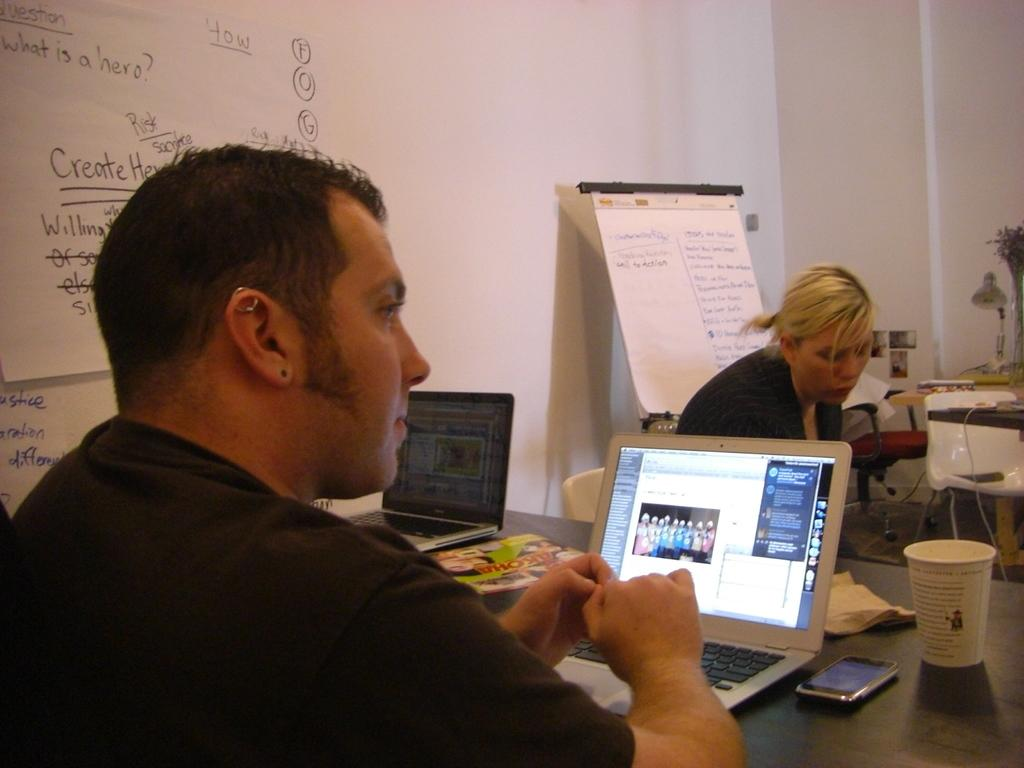What is the main subject of the image? There is a person sitting at the center of the image. What object is on the table in the image? There is a laptop on the table. Can you describe the background of the image? There is another lady in the background of the image, and there is a wall visible in the background. What type of regret can be seen on the person's face in the image? There is no indication of regret on the person's face in the image. Is there a sofa visible in the image? No, there is no sofa present in the image. 